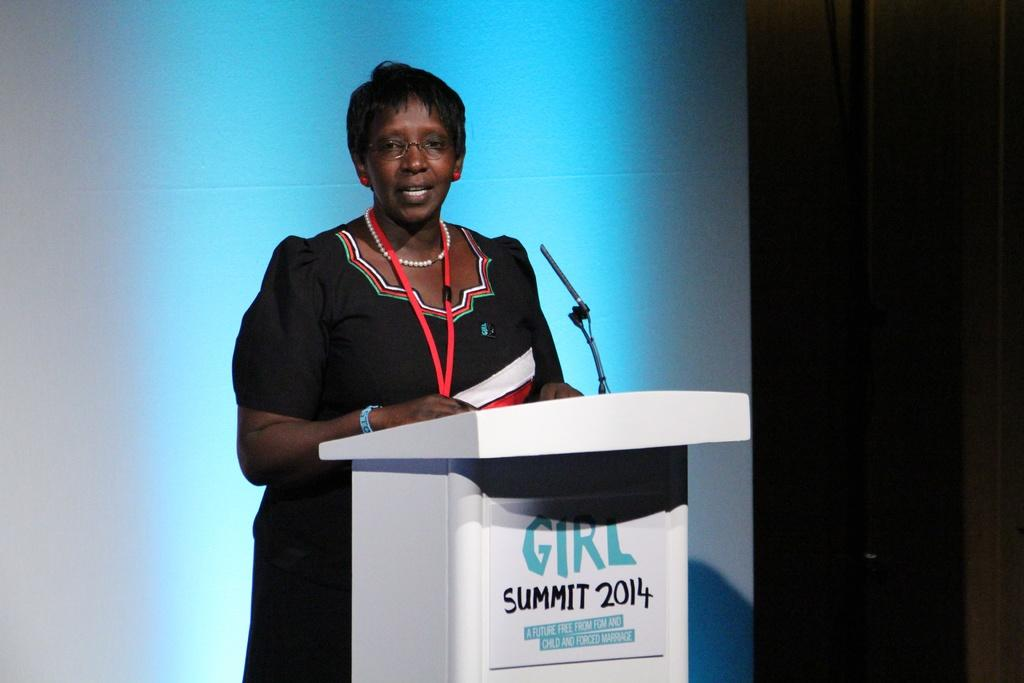<image>
Present a compact description of the photo's key features. A woman stands behind a podium at the Girl Summit in 2014. 